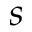<formula> <loc_0><loc_0><loc_500><loc_500>s</formula> 